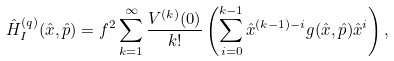Convert formula to latex. <formula><loc_0><loc_0><loc_500><loc_500>\hat { H } ^ { ( q ) } _ { I } ( \hat { x } , \hat { p } ) = f ^ { 2 } \sum _ { k = 1 } ^ { \infty } \frac { V ^ { ( k ) } ( 0 ) } { k ! } \left ( \sum _ { i = 0 } ^ { k - 1 } \hat { x } ^ { ( k - 1 ) - i } g ( \hat { x } , \hat { p } ) \hat { x } ^ { i } \right ) ,</formula> 